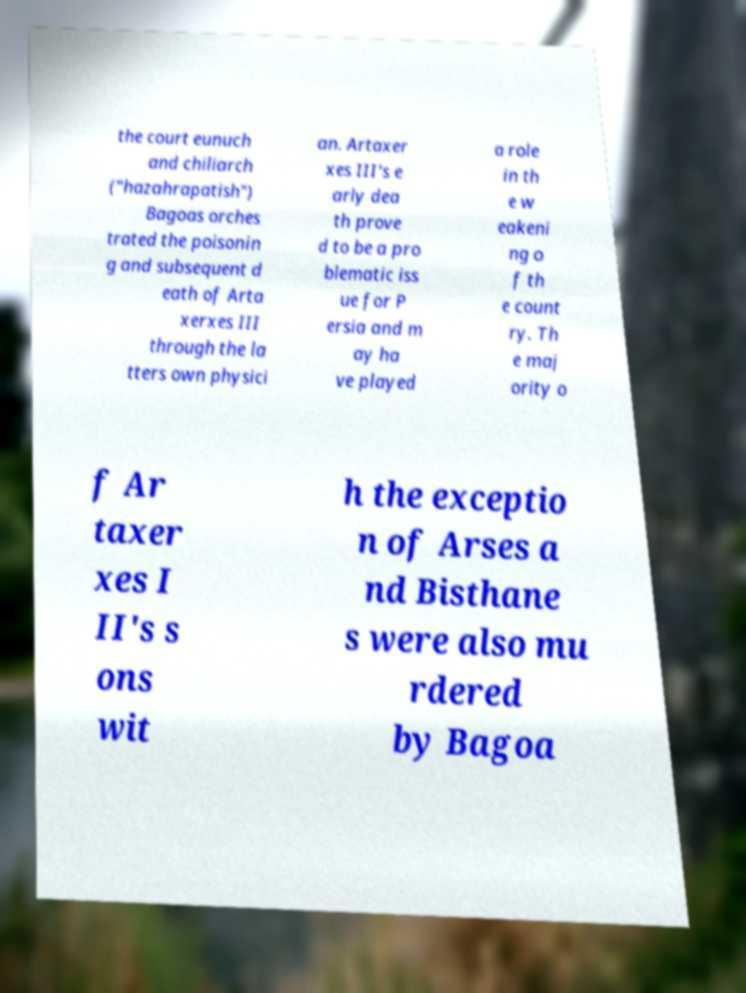Can you accurately transcribe the text from the provided image for me? the court eunuch and chiliarch ("hazahrapatish") Bagoas orches trated the poisonin g and subsequent d eath of Arta xerxes III through the la tters own physici an. Artaxer xes III's e arly dea th prove d to be a pro blematic iss ue for P ersia and m ay ha ve played a role in th e w eakeni ng o f th e count ry. Th e maj ority o f Ar taxer xes I II's s ons wit h the exceptio n of Arses a nd Bisthane s were also mu rdered by Bagoa 